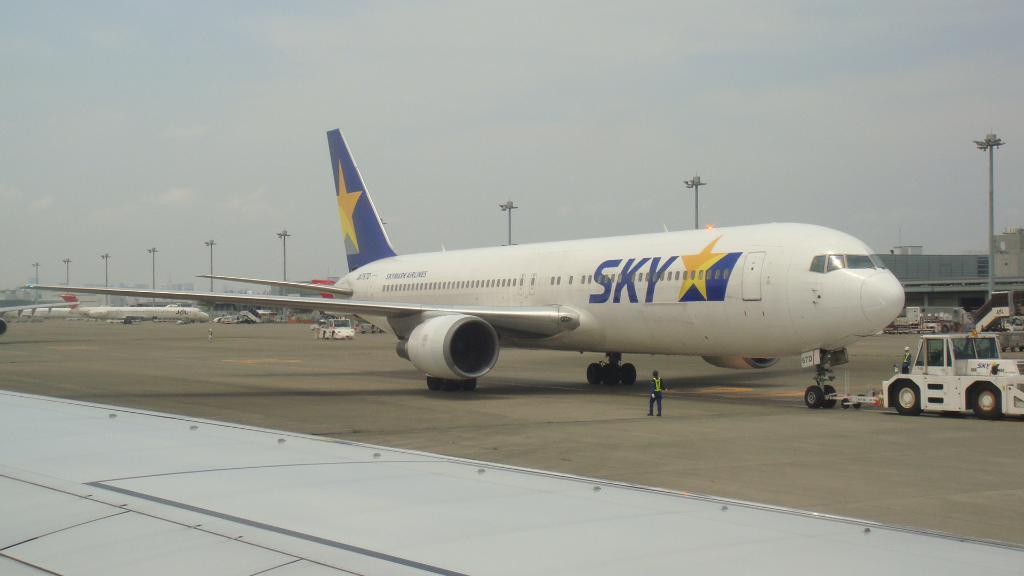How would you summarize this image in a sentence or two? In this image, we can see few aeroplanes, vehicles, people, poles with lights, road. Background we can see the sky. 